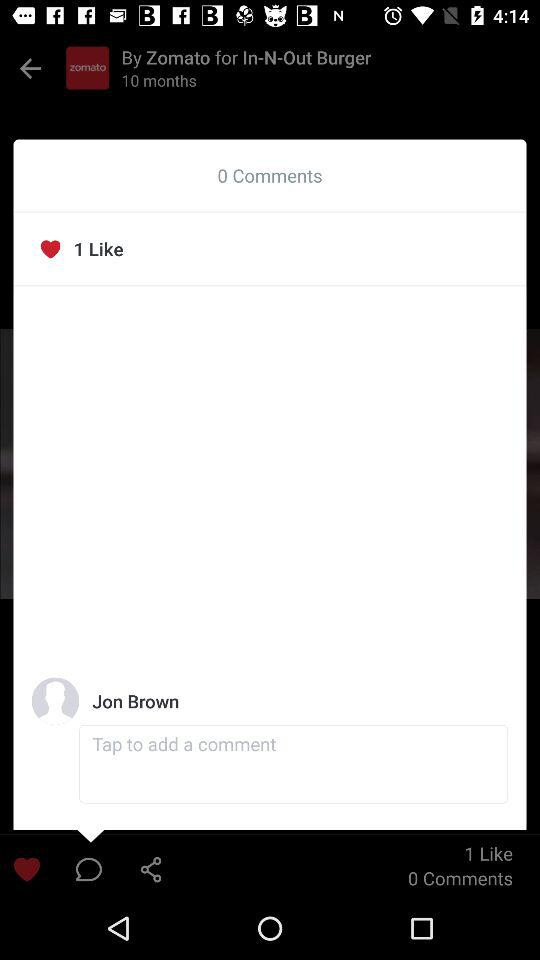What is the user name? The user name is "John Brown". 